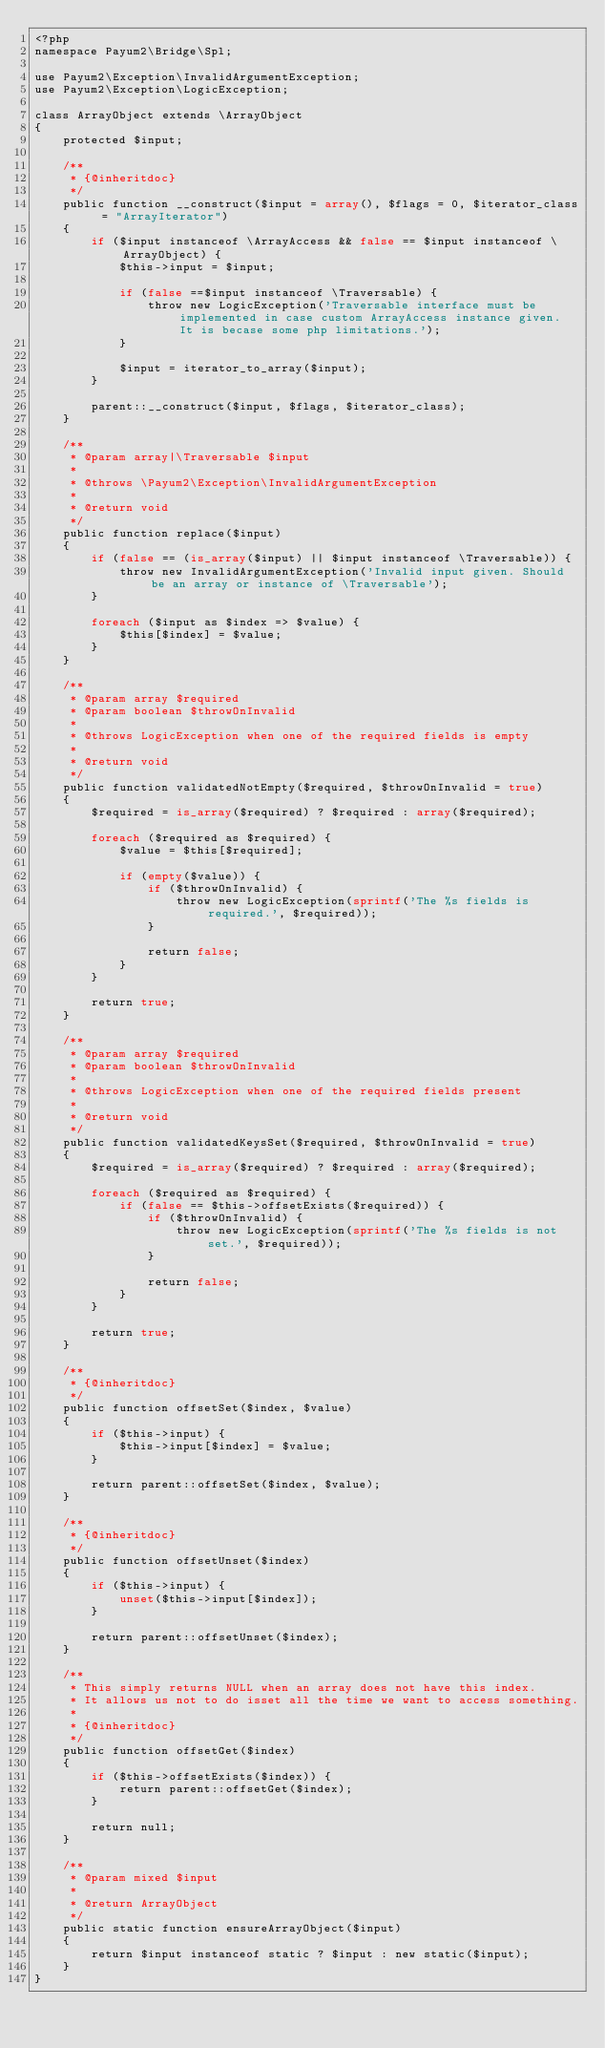Convert code to text. <code><loc_0><loc_0><loc_500><loc_500><_PHP_><?php
namespace Payum2\Bridge\Spl;

use Payum2\Exception\InvalidArgumentException;
use Payum2\Exception\LogicException;

class ArrayObject extends \ArrayObject
{
    protected $input;

    /**
     * {@inheritdoc}
     */
    public function __construct($input = array(), $flags = 0, $iterator_class = "ArrayIterator")
    {
        if ($input instanceof \ArrayAccess && false == $input instanceof \ArrayObject) {
            $this->input = $input;

            if (false ==$input instanceof \Traversable) {
                throw new LogicException('Traversable interface must be implemented in case custom ArrayAccess instance given. It is becase some php limitations.');
            }

            $input = iterator_to_array($input);
        }

        parent::__construct($input, $flags, $iterator_class);
    }

    /**
     * @param array|\Traversable $input
     *
     * @throws \Payum2\Exception\InvalidArgumentException
     *
     * @return void
     */
    public function replace($input)
    {
        if (false == (is_array($input) || $input instanceof \Traversable)) {
            throw new InvalidArgumentException('Invalid input given. Should be an array or instance of \Traversable');
        }

        foreach ($input as $index => $value) {
            $this[$index] = $value;
        }
    }

    /**
     * @param array $required
     * @param boolean $throwOnInvalid
     * 
     * @throws LogicException when one of the required fields is empty
     * 
     * @return void
     */
    public function validatedNotEmpty($required, $throwOnInvalid = true)
    {
        $required = is_array($required) ? $required : array($required);
        
        foreach ($required as $required) {
            $value = $this[$required];
            
            if (empty($value)) {
                if ($throwOnInvalid) {
                    throw new LogicException(sprintf('The %s fields is required.', $required));
                }

                return false;
            }
        }
        
        return true;
    }

    /**
     * @param array $required
     * @param boolean $throwOnInvalid
     *
     * @throws LogicException when one of the required fields present
     *
     * @return void
     */
    public function validatedKeysSet($required, $throwOnInvalid = true)
    {
        $required = is_array($required) ? $required : array($required);

        foreach ($required as $required) {
            if (false == $this->offsetExists($required)) {
                if ($throwOnInvalid) {
                    throw new LogicException(sprintf('The %s fields is not set.', $required));
                }

                return false;
            }
        }

        return true;
    }

    /**
     * {@inheritdoc}
     */
    public function offsetSet($index, $value)
    {
        if ($this->input) {
            $this->input[$index] = $value;
        }

        return parent::offsetSet($index, $value);
    }

    /**
     * {@inheritdoc}
     */
    public function offsetUnset($index)
    {
        if ($this->input) {
            unset($this->input[$index]);
        }

        return parent::offsetUnset($index);
    }

    /**
     * This simply returns NULL when an array does not have this index.
     * It allows us not to do isset all the time we want to access something.
     *
     * {@inheritdoc}
     */
    public function offsetGet($index)
    {
        if ($this->offsetExists($index)) {
            return parent::offsetGet($index);
        }

        return null;
    }

    /**
     * @param mixed $input
     * 
     * @return ArrayObject
     */
    public static function ensureArrayObject($input)
    {
        return $input instanceof static ? $input : new static($input);
    }
}</code> 